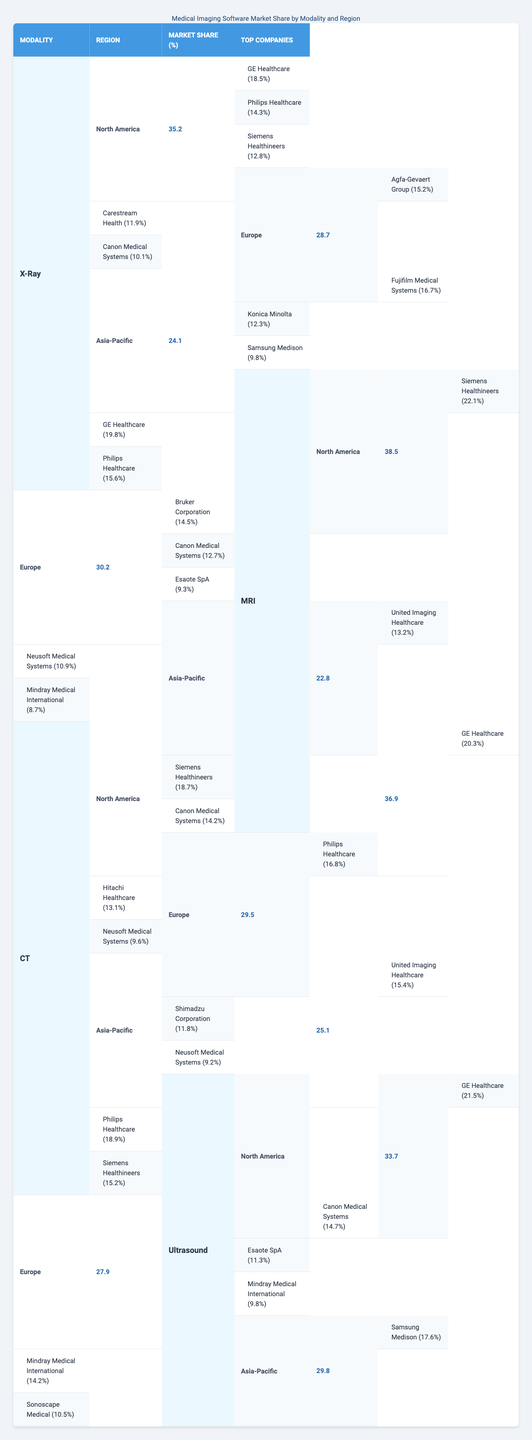What is the market share of X-Ray software in North America? The table shows that the market share of X-Ray software in North America is 35.2%.
Answer: 35.2% Which company has the highest market share in the MRI modality in Europe? According to the table, Bruker Corporation has the highest market share in the MRI modality in Europe at 14.5%.
Answer: Bruker Corporation What is the total market share of medical imaging software in Asia-Pacific across all modalities? The market shares in Asia-Pacific for X-Ray, MRI, CT, and Ultrasound are 24.1%, 22.8%, 25.1%, and 29.8%, respectively. The total is 24.1 + 22.8 + 25.1 + 29.8 = 101.8%.
Answer: 101.8% Is Siemens Healthineers a top company for both X-Ray and Ultrasound modalities in North America? Yes, Siemens Healthineers is listed as a top company for both X-Ray and Ultrasound modalities in North America, with shares of 12.8% and 15.2%, respectively.
Answer: Yes Which modality has the lowest market share in Europe, and what is that percentage? By comparing the market shares of different modalities in Europe, X-Ray has the lowest share at 28.7%.
Answer: 28.7% Who are the top three companies in CT software in North America? The top three companies in CT software in North America are GE Healthcare (20.3%), Siemens Healthineers (18.7%), and Canon Medical Systems (14.2%).
Answer: GE Healthcare, Siemens Healthineers, Canon Medical Systems What is the average market share of MRI software in the Asia-Pacific region? The market shares of MRI software in Asia-Pacific from three companies sum up as 13.2%, 10.9%, and 8.7%. The average is (13.2 + 10.9 + 8.7) / 3 = 10.9%.
Answer: 10.9% Which region has the highest market share for Ultrasound software? North America has the highest market share for Ultrasound software at 33.7%.
Answer: North America Which company has a market share of 12.3% in Asia-Pacific for X-Ray software? The company with a market share of 12.3% in Asia-Pacific for X-Ray software is Konica Minolta.
Answer: Konica Minolta How does the market share of MRI software in North America compare to that in Asia-Pacific? The market share of MRI software in North America is 38.5%, while in Asia-Pacific, it is 22.8%. So, North America has a higher market share by 15.7%.
Answer: Higher by 15.7% 